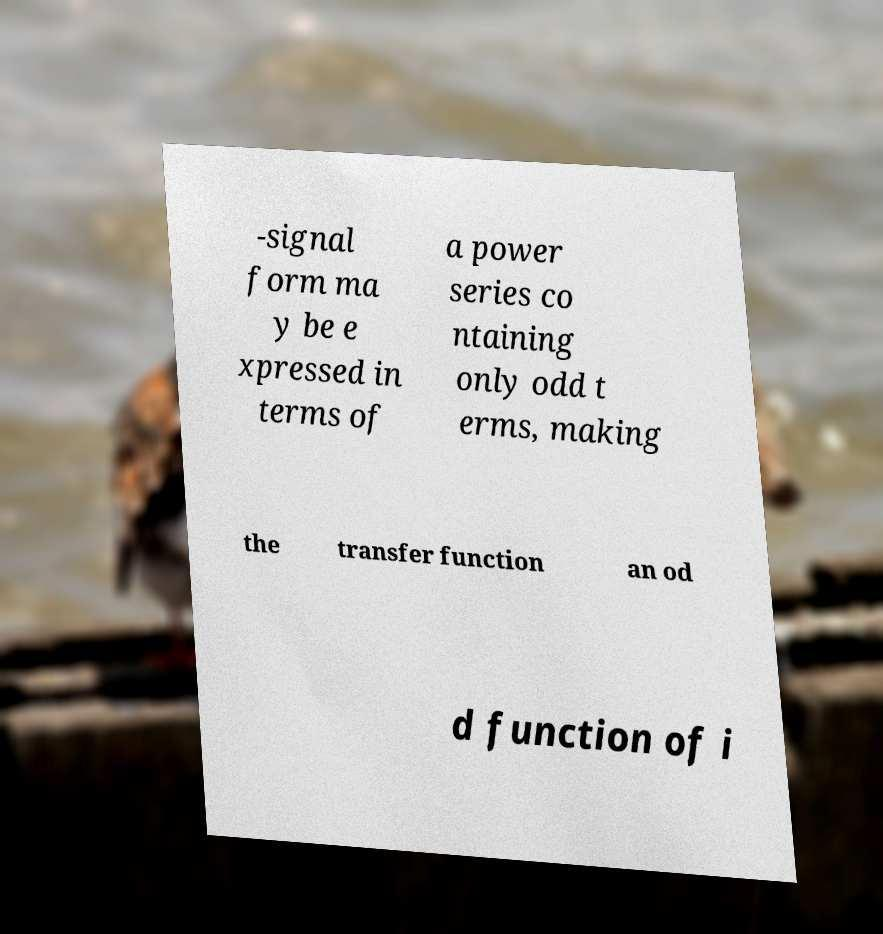Can you accurately transcribe the text from the provided image for me? -signal form ma y be e xpressed in terms of a power series co ntaining only odd t erms, making the transfer function an od d function of i 